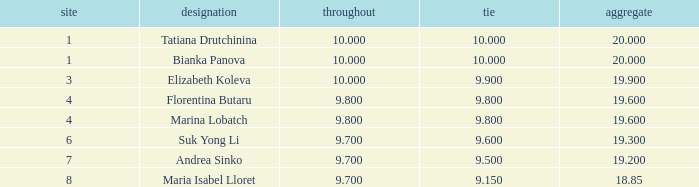In which place was a ribbon's score under 9.8 and the total points equal to 19.2? 7.0. 